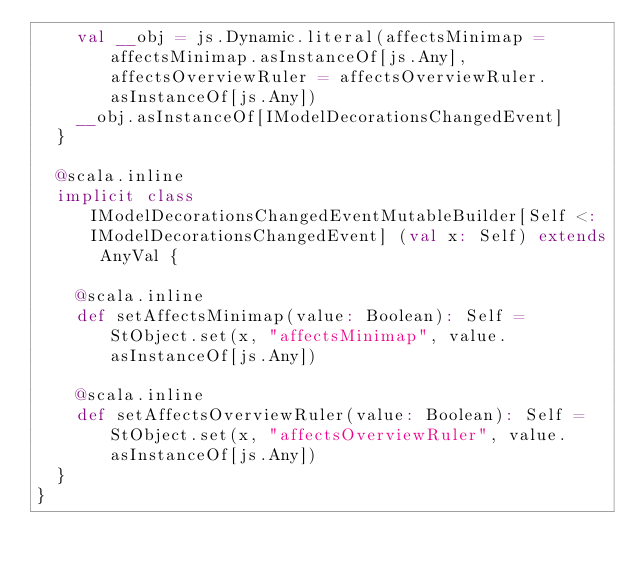Convert code to text. <code><loc_0><loc_0><loc_500><loc_500><_Scala_>    val __obj = js.Dynamic.literal(affectsMinimap = affectsMinimap.asInstanceOf[js.Any], affectsOverviewRuler = affectsOverviewRuler.asInstanceOf[js.Any])
    __obj.asInstanceOf[IModelDecorationsChangedEvent]
  }
  
  @scala.inline
  implicit class IModelDecorationsChangedEventMutableBuilder[Self <: IModelDecorationsChangedEvent] (val x: Self) extends AnyVal {
    
    @scala.inline
    def setAffectsMinimap(value: Boolean): Self = StObject.set(x, "affectsMinimap", value.asInstanceOf[js.Any])
    
    @scala.inline
    def setAffectsOverviewRuler(value: Boolean): Self = StObject.set(x, "affectsOverviewRuler", value.asInstanceOf[js.Any])
  }
}
</code> 